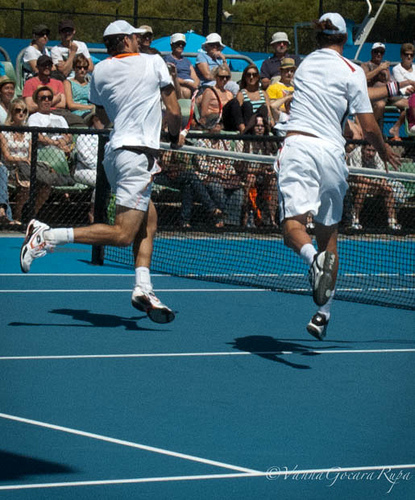Please transcribe the text in this image. Vanna Gocara Rupa 